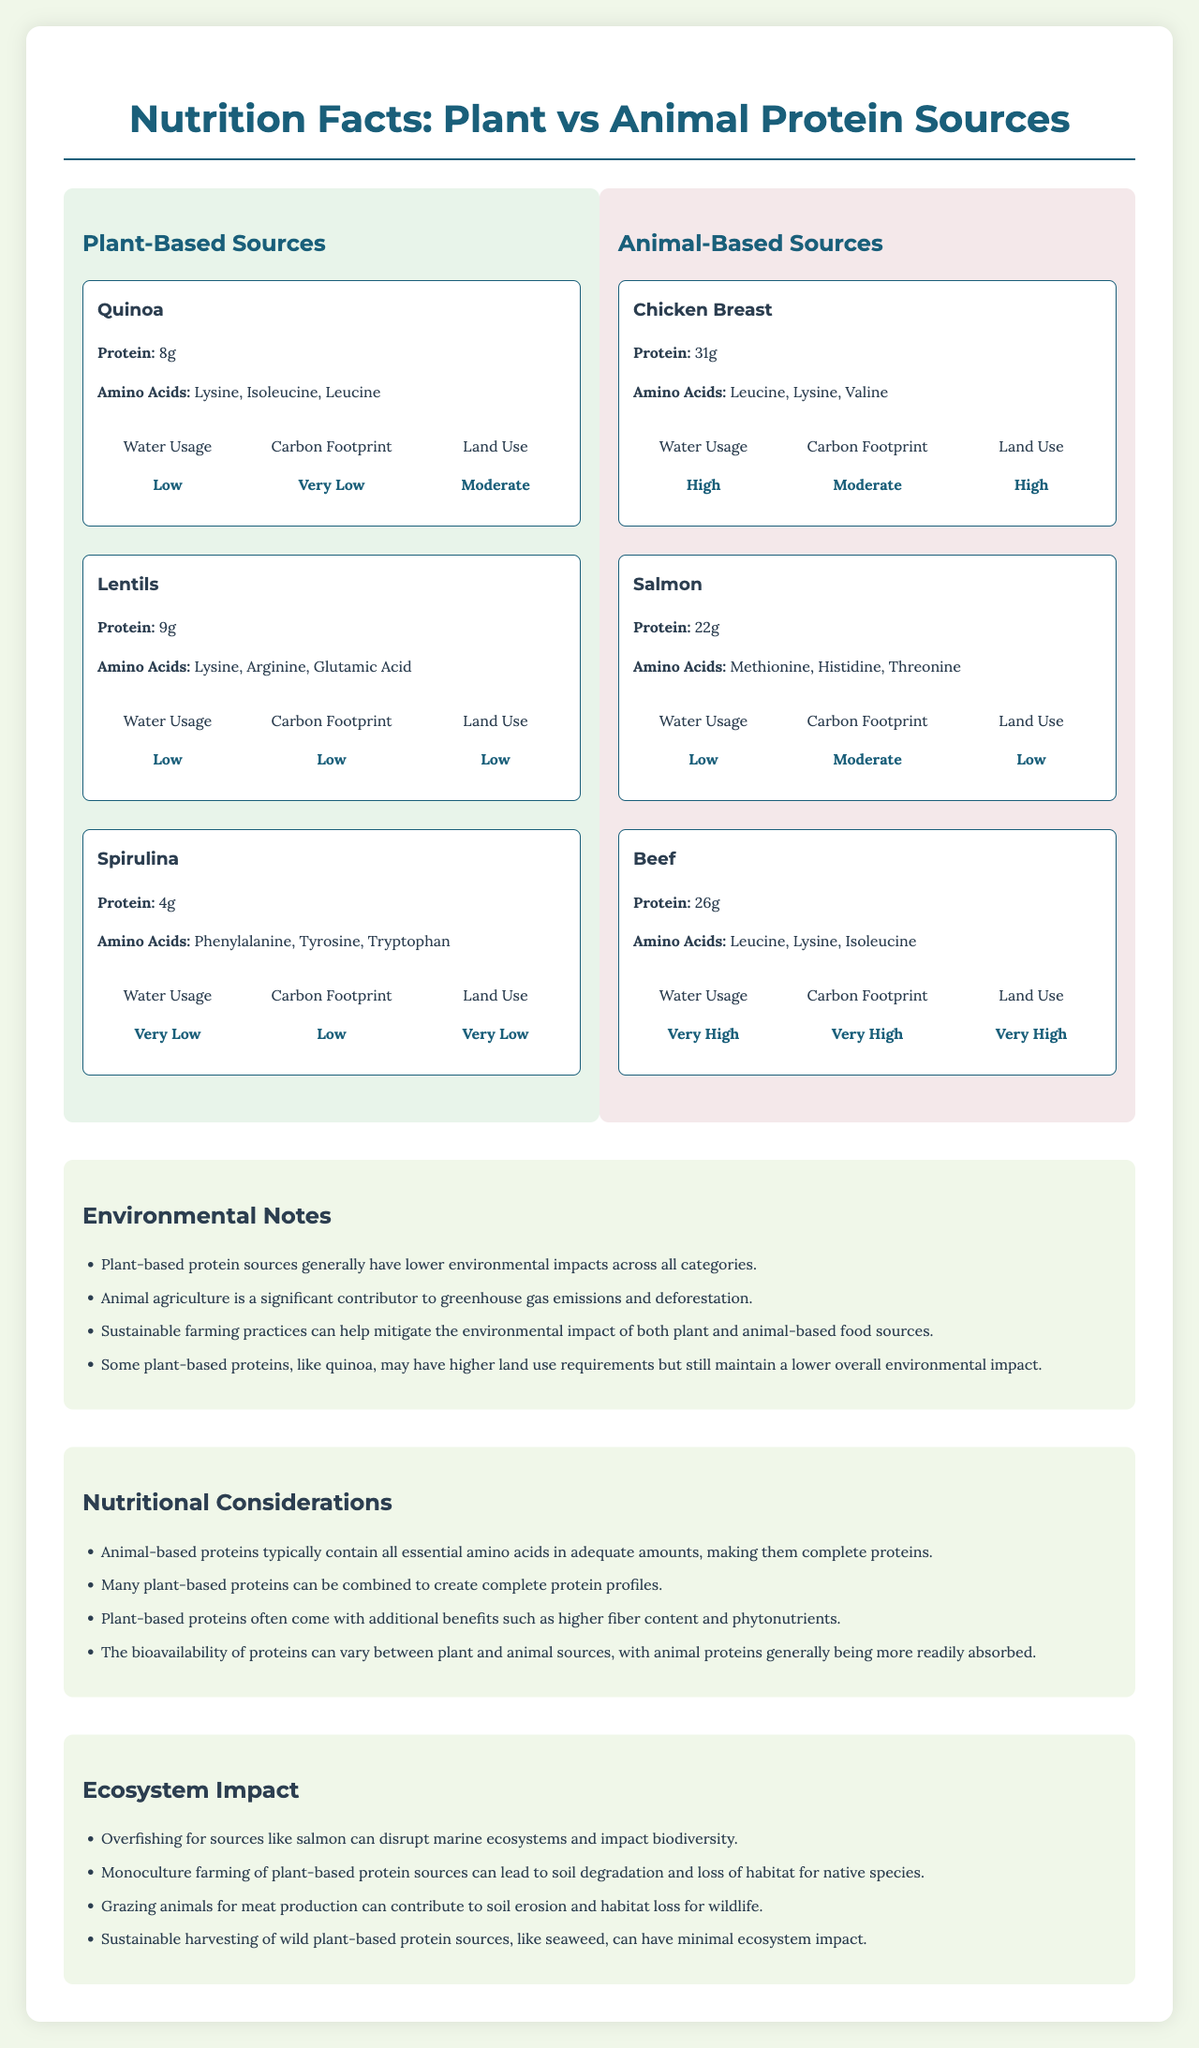what is the protein content of Quinoa? The document states that quinoa has 8 grams of protein.
Answer: 8g which plant-based source has the highest protein content? Lentils have 9 grams of protein, which is higher than both Quinoa and Spirulina.
Answer: Lentils Which of the following animal-based sources has the lowest carbon footprint? A. Chicken Breast B. Salmon C. Beef Salmon has a "Moderate" level of carbon footprint, while Chicken Breast has a "Moderate" and Beef has a "Very High" carbon footprint.
Answer: B What amino acids are present in Beef? The document lists these amino acids under Beef.
Answer: Leucine, Lysine, Isoleucine Does Spirulina have a higher or lower land use compared to Chicken Breast? Spirulina has a "Very Low" land use whereas Chicken Breast has a "High" land use.
Answer: Lower Which source has the highest water usage among all the sources? The document states that Beef has a "Very High" water usage.
Answer: Beef Is it true that quinoa requires more land use than lentils? The environmental impact section states that quinoa's land use is "Moderate" whereas lentils' land use is "Low".
Answer: Yes Could sustainable farming practices mitigate the environmental impact of both plant and animal-based food sources? The document notes that sustainable farming practices can help mitigate the environmental impact of both types of food sources.
Answer: Yes Summarize the main findings of the document. The document thoroughly compares the nutritional and environmental aspects of both plant-based and animal-based protein sources, highlighting their respective benefits and drawbacks, while also advocating for sustainable agricultural practices.
Answer: The document compares plant-based and animal-based protein sources regarding their protein content, amino acids, and environmental impacts. It highlights that plant-based proteins generally have lower environmental impacts, but animal-based proteins tend to provide complete amino acid profiles. Environmental notes and nutritional considerations emphasize the importance of sustainable practices for minimizing ecological footprints. What is the total carbon footprint of all animal-based sources combined? The document provides individual carbon footprint levels but does not quantify them numerically, making it impossible to sum up the total carbon footprint.
Answer: Not enough information What are some potential drawbacks of monoculture farming for plant-based protein sources? The document mentions that monoculture farming can lead to these environmental issues.
Answer: Soil degradation and loss of habitat for native species 